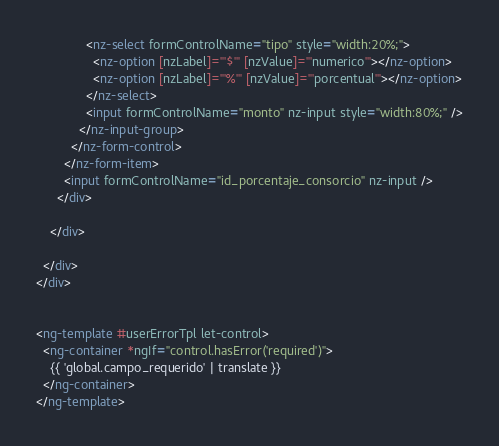Convert code to text. <code><loc_0><loc_0><loc_500><loc_500><_HTML_>              <nz-select formControlName="tipo" style="width:20%;">
                <nz-option [nzLabel]="'$'" [nzValue]="'numerico'"></nz-option>
                <nz-option [nzLabel]="'%'" [nzValue]="'porcentual'"></nz-option>
              </nz-select>
              <input formControlName="monto" nz-input style="width:80%;" />
            </nz-input-group>
          </nz-form-control>
        </nz-form-item>
        <input formControlName="id_porcentaje_consorcio" nz-input />
      </div>

    </div>

  </div>
</div>


<ng-template #userErrorTpl let-control>
  <ng-container *ngIf="control.hasError('required')">
    {{ 'global.campo_requerido' | translate }}
  </ng-container>
</ng-template>
</code> 